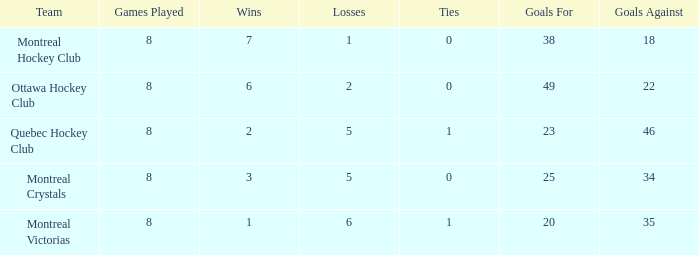What is the average losses when the wins is 3? 5.0. 